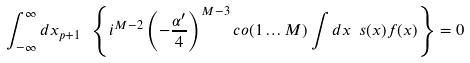<formula> <loc_0><loc_0><loc_500><loc_500>\int _ { - \infty } ^ { \infty } d x _ { p + 1 } \ \left \{ i ^ { M - 2 } \left ( - \frac { \alpha ^ { \prime } } { 4 } \right ) ^ { M - 3 } c o ( 1 \dots M ) \int d x \ s ( x ) f ( x ) \right \} = 0</formula> 